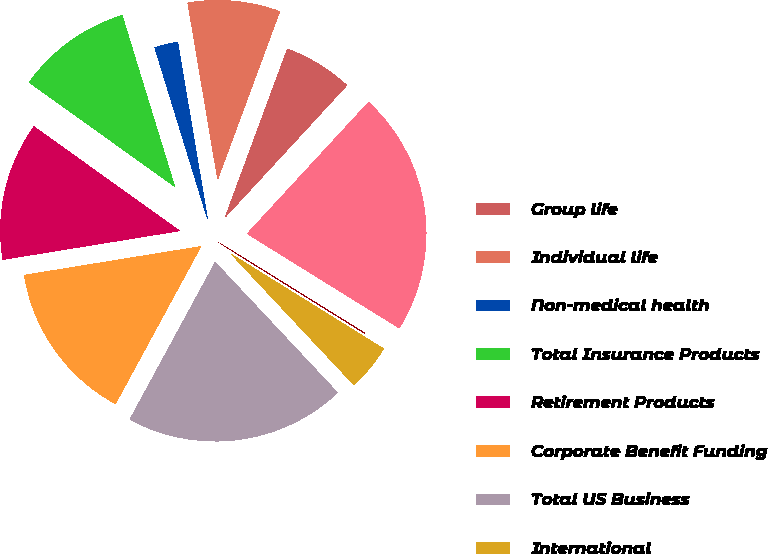Convert chart. <chart><loc_0><loc_0><loc_500><loc_500><pie_chart><fcel>Group life<fcel>Individual life<fcel>Non-medical health<fcel>Total Insurance Products<fcel>Retirement Products<fcel>Corporate Benefit Funding<fcel>Total US Business<fcel>International<fcel>Banking Corporate & Other<fcel>Total<nl><fcel>6.23%<fcel>8.3%<fcel>2.08%<fcel>10.37%<fcel>12.45%<fcel>14.52%<fcel>19.91%<fcel>4.16%<fcel>0.01%<fcel>21.98%<nl></chart> 